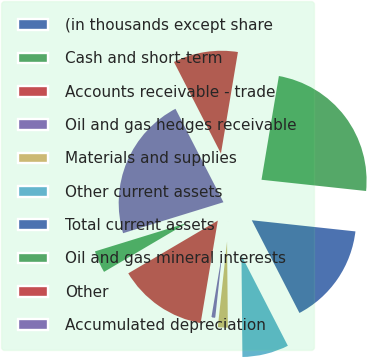Convert chart. <chart><loc_0><loc_0><loc_500><loc_500><pie_chart><fcel>(in thousands except share<fcel>Cash and short-term<fcel>Accounts receivable - trade<fcel>Oil and gas hedges receivable<fcel>Materials and supplies<fcel>Other current assets<fcel>Total current assets<fcel>Oil and gas mineral interests<fcel>Other<fcel>Accumulated depreciation<nl><fcel>0.0%<fcel>3.71%<fcel>13.89%<fcel>0.93%<fcel>1.86%<fcel>7.41%<fcel>15.74%<fcel>24.07%<fcel>10.19%<fcel>22.22%<nl></chart> 